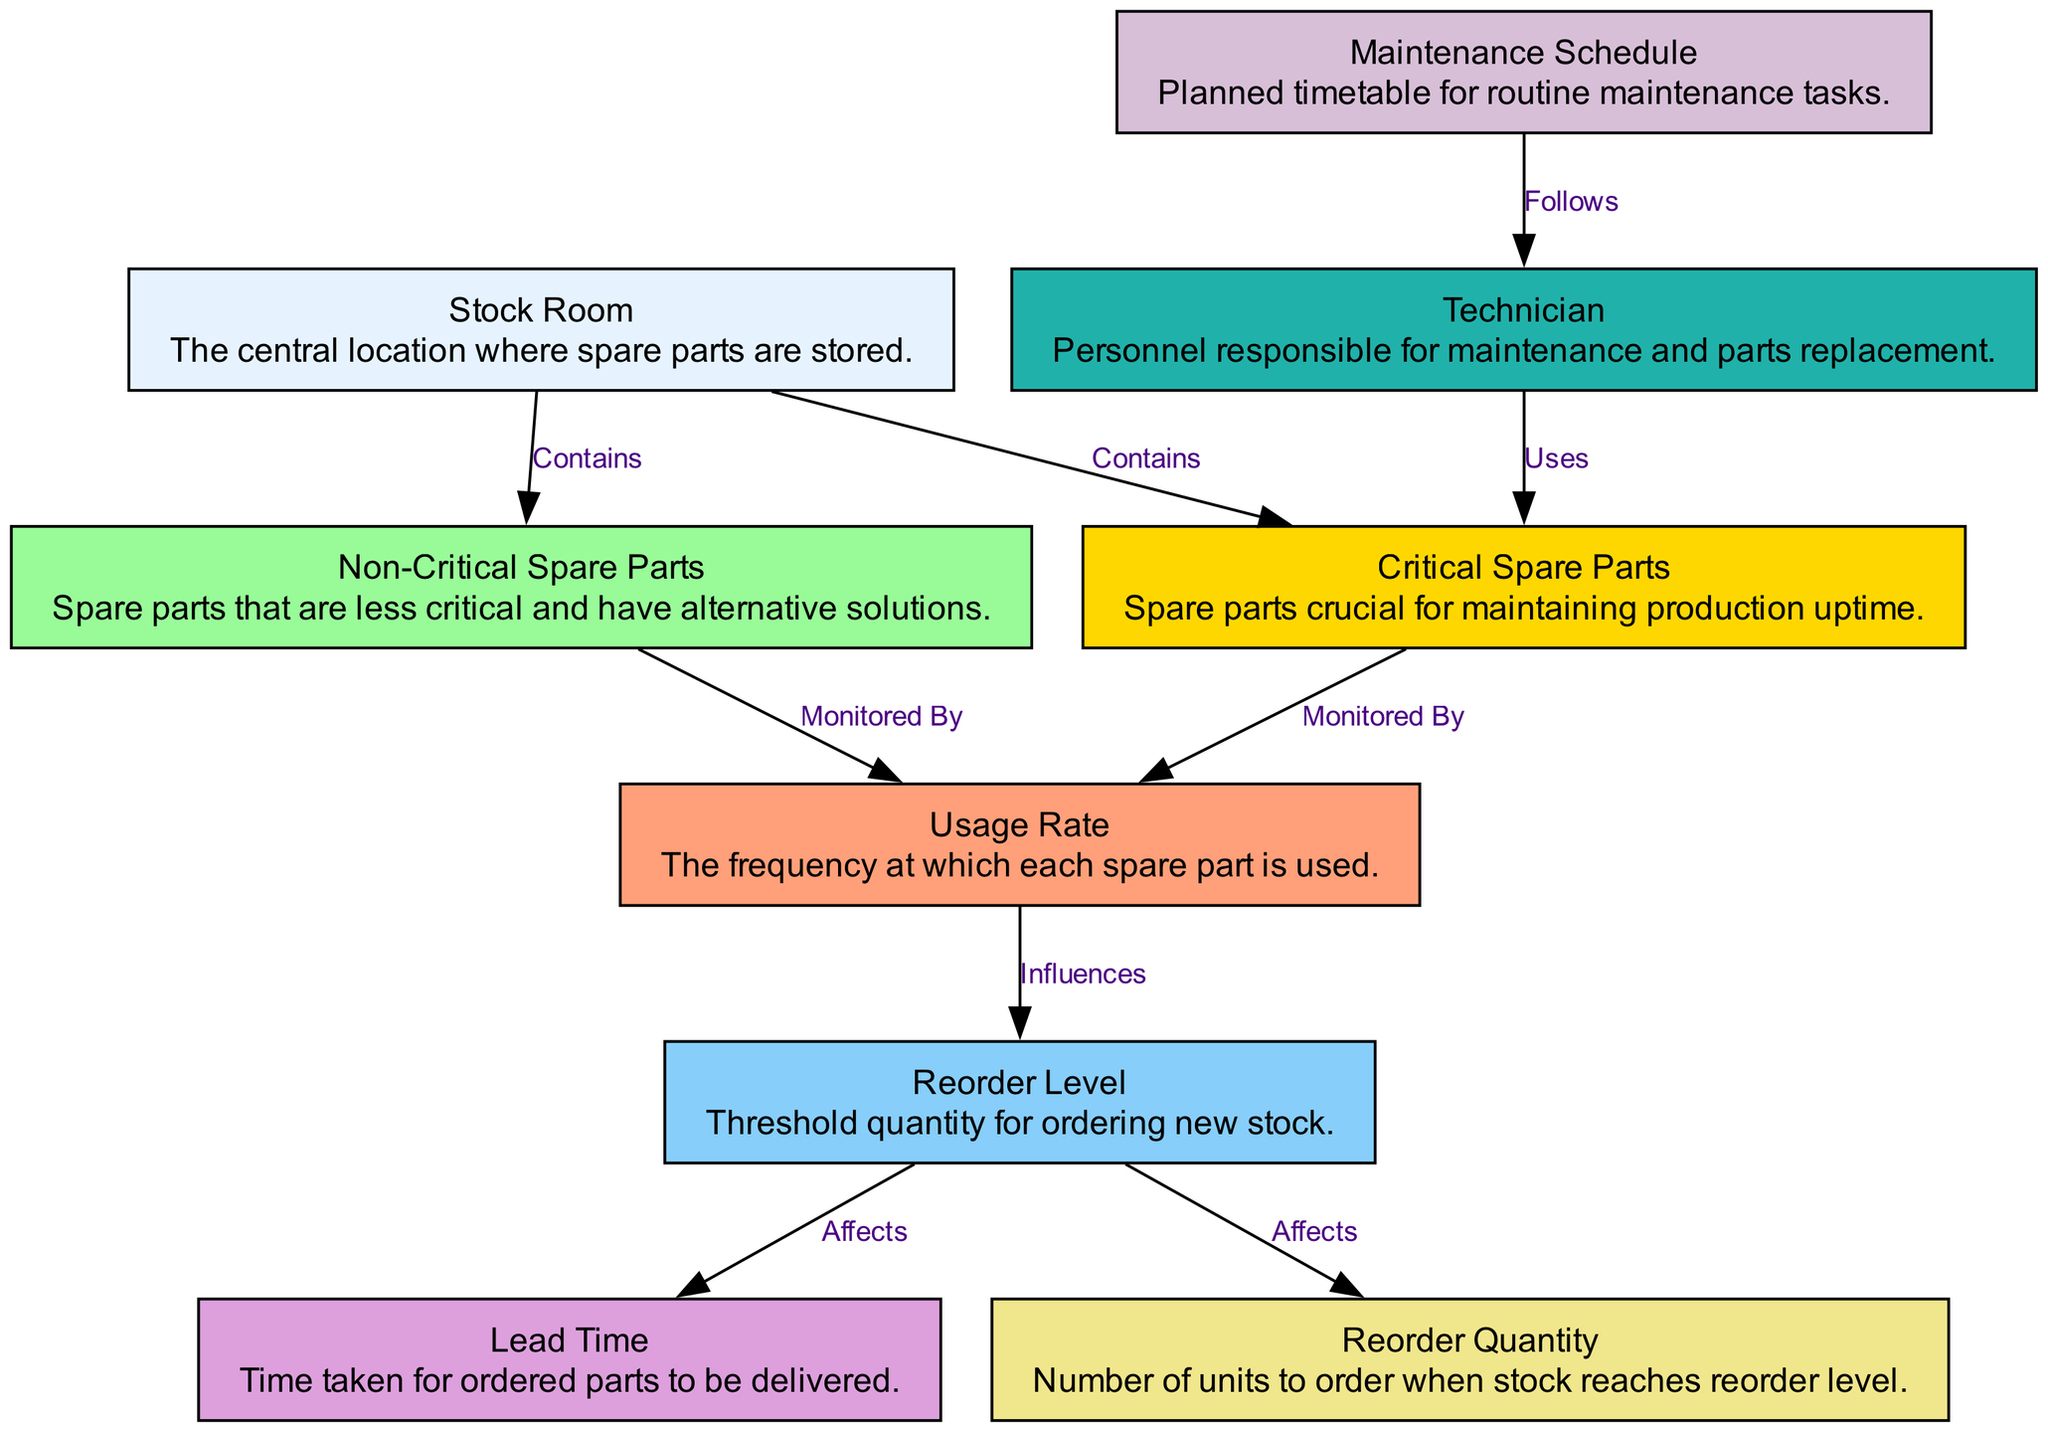What is the central location where spare parts are stored? The diagram describes the "Stock Room" as the central location where spare parts are stored. This information is directly stated in the description of the node labeled "Stock Room."
Answer: Stock Room Which spare parts are crucial for maintaining production uptime? The diagram identifies "Critical Spare Parts" as the spare parts that are crucial for maintaining production uptime. This is confirmed by the title of the respective node.
Answer: Critical Spare Parts How many types of spare parts are mentioned in the diagram? There are two types of spare parts listed in the diagram: "Critical Spare Parts" and "Non-Critical Spare Parts." This can be determined by counting the specific nodes related to spare parts.
Answer: Two What influences the reorder level? The "Usage Rate" influences the "Reorder Level." This relationship is indicated by the edge labeled "Influences" connecting these two nodes.
Answer: Usage Rate What follows the maintenance schedule? The "Technician" follows the "Maintenance Schedule." This is illustrated through the edge labeled "Follows" that connects these two nodes.
Answer: Technician What affects the lead time? The "Reorder Level" affects the "Lead Time." The edge labeled "Affects" shows this relationship, indicating that the reorder level has consequences on how long it takes for parts to be delivered.
Answer: Reorder Level How many edges are present in the diagram? The diagram has a total of eight edges, as evidenced by counting each relationship depicted between the nodes.
Answer: Eight What does the technician use? The technician uses "Critical Spare Parts." This relationship is shown in the diagram by the edge labeled "Uses" from "Technician" to "Critical Spare Parts."
Answer: Critical Spare Parts What is the lead time's role in relation to reorder levels? The lead time's role is affected by the "Reorder Level," as indicated by the edge labeled "Affects." This shows the importance of understanding reorder levels in managing lead times for spare parts delivery.
Answer: Affects What is the usage rate's function in the inventory system? The usage rate serves to monitor "Critical Spare Parts" and "Non-Critical Spare Parts." This dual function is shown by edges labeled "Monitored By" connecting both types of parts to the usage rate.
Answer: Monitored By 